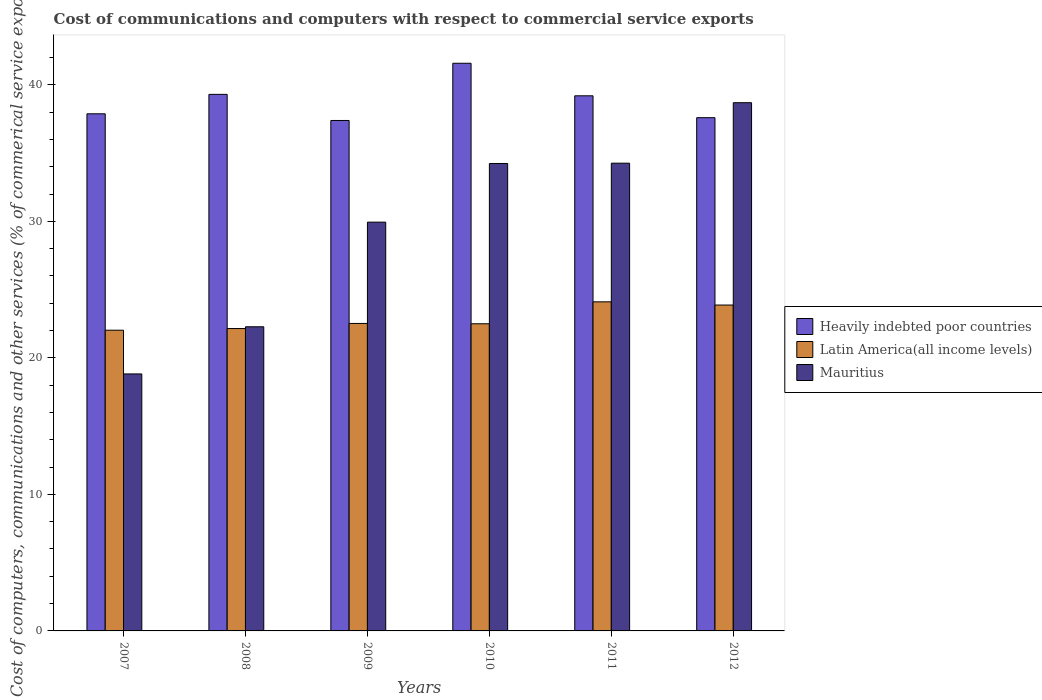How many groups of bars are there?
Provide a succinct answer. 6. What is the label of the 1st group of bars from the left?
Provide a succinct answer. 2007. What is the cost of communications and computers in Heavily indebted poor countries in 2012?
Offer a terse response. 37.59. Across all years, what is the maximum cost of communications and computers in Heavily indebted poor countries?
Keep it short and to the point. 41.58. Across all years, what is the minimum cost of communications and computers in Latin America(all income levels)?
Your response must be concise. 22.02. In which year was the cost of communications and computers in Heavily indebted poor countries maximum?
Your response must be concise. 2010. In which year was the cost of communications and computers in Heavily indebted poor countries minimum?
Give a very brief answer. 2009. What is the total cost of communications and computers in Latin America(all income levels) in the graph?
Your answer should be compact. 137.16. What is the difference between the cost of communications and computers in Mauritius in 2009 and that in 2010?
Provide a succinct answer. -4.3. What is the difference between the cost of communications and computers in Heavily indebted poor countries in 2007 and the cost of communications and computers in Mauritius in 2012?
Ensure brevity in your answer.  -0.81. What is the average cost of communications and computers in Mauritius per year?
Make the answer very short. 29.7. In the year 2012, what is the difference between the cost of communications and computers in Latin America(all income levels) and cost of communications and computers in Heavily indebted poor countries?
Make the answer very short. -13.72. In how many years, is the cost of communications and computers in Latin America(all income levels) greater than 16 %?
Your response must be concise. 6. What is the ratio of the cost of communications and computers in Heavily indebted poor countries in 2007 to that in 2008?
Keep it short and to the point. 0.96. Is the difference between the cost of communications and computers in Latin America(all income levels) in 2009 and 2012 greater than the difference between the cost of communications and computers in Heavily indebted poor countries in 2009 and 2012?
Make the answer very short. No. What is the difference between the highest and the second highest cost of communications and computers in Mauritius?
Offer a terse response. 4.43. What is the difference between the highest and the lowest cost of communications and computers in Latin America(all income levels)?
Provide a succinct answer. 2.08. In how many years, is the cost of communications and computers in Latin America(all income levels) greater than the average cost of communications and computers in Latin America(all income levels) taken over all years?
Your answer should be compact. 2. What does the 3rd bar from the left in 2007 represents?
Your answer should be compact. Mauritius. What does the 3rd bar from the right in 2010 represents?
Ensure brevity in your answer.  Heavily indebted poor countries. Are all the bars in the graph horizontal?
Make the answer very short. No. What is the difference between two consecutive major ticks on the Y-axis?
Keep it short and to the point. 10. Does the graph contain any zero values?
Your answer should be compact. No. Does the graph contain grids?
Keep it short and to the point. No. How many legend labels are there?
Make the answer very short. 3. What is the title of the graph?
Provide a short and direct response. Cost of communications and computers with respect to commercial service exports. What is the label or title of the Y-axis?
Provide a short and direct response. Cost of computers, communications and other services (% of commerical service exports). What is the Cost of computers, communications and other services (% of commerical service exports) of Heavily indebted poor countries in 2007?
Make the answer very short. 37.87. What is the Cost of computers, communications and other services (% of commerical service exports) in Latin America(all income levels) in 2007?
Give a very brief answer. 22.02. What is the Cost of computers, communications and other services (% of commerical service exports) in Mauritius in 2007?
Your answer should be compact. 18.82. What is the Cost of computers, communications and other services (% of commerical service exports) of Heavily indebted poor countries in 2008?
Your response must be concise. 39.3. What is the Cost of computers, communications and other services (% of commerical service exports) in Latin America(all income levels) in 2008?
Your answer should be very brief. 22.15. What is the Cost of computers, communications and other services (% of commerical service exports) in Mauritius in 2008?
Give a very brief answer. 22.28. What is the Cost of computers, communications and other services (% of commerical service exports) in Heavily indebted poor countries in 2009?
Give a very brief answer. 37.39. What is the Cost of computers, communications and other services (% of commerical service exports) of Latin America(all income levels) in 2009?
Provide a short and direct response. 22.52. What is the Cost of computers, communications and other services (% of commerical service exports) of Mauritius in 2009?
Ensure brevity in your answer.  29.94. What is the Cost of computers, communications and other services (% of commerical service exports) of Heavily indebted poor countries in 2010?
Your answer should be very brief. 41.58. What is the Cost of computers, communications and other services (% of commerical service exports) in Latin America(all income levels) in 2010?
Your answer should be compact. 22.5. What is the Cost of computers, communications and other services (% of commerical service exports) in Mauritius in 2010?
Offer a terse response. 34.24. What is the Cost of computers, communications and other services (% of commerical service exports) of Heavily indebted poor countries in 2011?
Your answer should be very brief. 39.19. What is the Cost of computers, communications and other services (% of commerical service exports) of Latin America(all income levels) in 2011?
Your answer should be compact. 24.1. What is the Cost of computers, communications and other services (% of commerical service exports) in Mauritius in 2011?
Give a very brief answer. 34.26. What is the Cost of computers, communications and other services (% of commerical service exports) in Heavily indebted poor countries in 2012?
Provide a succinct answer. 37.59. What is the Cost of computers, communications and other services (% of commerical service exports) in Latin America(all income levels) in 2012?
Provide a succinct answer. 23.87. What is the Cost of computers, communications and other services (% of commerical service exports) of Mauritius in 2012?
Your response must be concise. 38.69. Across all years, what is the maximum Cost of computers, communications and other services (% of commerical service exports) of Heavily indebted poor countries?
Offer a very short reply. 41.58. Across all years, what is the maximum Cost of computers, communications and other services (% of commerical service exports) in Latin America(all income levels)?
Provide a succinct answer. 24.1. Across all years, what is the maximum Cost of computers, communications and other services (% of commerical service exports) of Mauritius?
Make the answer very short. 38.69. Across all years, what is the minimum Cost of computers, communications and other services (% of commerical service exports) in Heavily indebted poor countries?
Provide a short and direct response. 37.39. Across all years, what is the minimum Cost of computers, communications and other services (% of commerical service exports) in Latin America(all income levels)?
Provide a short and direct response. 22.02. Across all years, what is the minimum Cost of computers, communications and other services (% of commerical service exports) of Mauritius?
Offer a terse response. 18.82. What is the total Cost of computers, communications and other services (% of commerical service exports) of Heavily indebted poor countries in the graph?
Your answer should be very brief. 232.92. What is the total Cost of computers, communications and other services (% of commerical service exports) of Latin America(all income levels) in the graph?
Your answer should be very brief. 137.16. What is the total Cost of computers, communications and other services (% of commerical service exports) of Mauritius in the graph?
Make the answer very short. 178.22. What is the difference between the Cost of computers, communications and other services (% of commerical service exports) in Heavily indebted poor countries in 2007 and that in 2008?
Keep it short and to the point. -1.42. What is the difference between the Cost of computers, communications and other services (% of commerical service exports) of Latin America(all income levels) in 2007 and that in 2008?
Give a very brief answer. -0.12. What is the difference between the Cost of computers, communications and other services (% of commerical service exports) of Mauritius in 2007 and that in 2008?
Your response must be concise. -3.45. What is the difference between the Cost of computers, communications and other services (% of commerical service exports) in Heavily indebted poor countries in 2007 and that in 2009?
Your response must be concise. 0.49. What is the difference between the Cost of computers, communications and other services (% of commerical service exports) in Latin America(all income levels) in 2007 and that in 2009?
Offer a very short reply. -0.5. What is the difference between the Cost of computers, communications and other services (% of commerical service exports) in Mauritius in 2007 and that in 2009?
Your answer should be compact. -11.12. What is the difference between the Cost of computers, communications and other services (% of commerical service exports) in Heavily indebted poor countries in 2007 and that in 2010?
Ensure brevity in your answer.  -3.7. What is the difference between the Cost of computers, communications and other services (% of commerical service exports) of Latin America(all income levels) in 2007 and that in 2010?
Make the answer very short. -0.47. What is the difference between the Cost of computers, communications and other services (% of commerical service exports) of Mauritius in 2007 and that in 2010?
Give a very brief answer. -15.41. What is the difference between the Cost of computers, communications and other services (% of commerical service exports) of Heavily indebted poor countries in 2007 and that in 2011?
Provide a short and direct response. -1.32. What is the difference between the Cost of computers, communications and other services (% of commerical service exports) of Latin America(all income levels) in 2007 and that in 2011?
Keep it short and to the point. -2.08. What is the difference between the Cost of computers, communications and other services (% of commerical service exports) of Mauritius in 2007 and that in 2011?
Offer a very short reply. -15.44. What is the difference between the Cost of computers, communications and other services (% of commerical service exports) of Heavily indebted poor countries in 2007 and that in 2012?
Offer a very short reply. 0.28. What is the difference between the Cost of computers, communications and other services (% of commerical service exports) in Latin America(all income levels) in 2007 and that in 2012?
Keep it short and to the point. -1.84. What is the difference between the Cost of computers, communications and other services (% of commerical service exports) in Mauritius in 2007 and that in 2012?
Provide a short and direct response. -19.87. What is the difference between the Cost of computers, communications and other services (% of commerical service exports) of Heavily indebted poor countries in 2008 and that in 2009?
Offer a terse response. 1.91. What is the difference between the Cost of computers, communications and other services (% of commerical service exports) of Latin America(all income levels) in 2008 and that in 2009?
Offer a terse response. -0.37. What is the difference between the Cost of computers, communications and other services (% of commerical service exports) of Mauritius in 2008 and that in 2009?
Offer a very short reply. -7.66. What is the difference between the Cost of computers, communications and other services (% of commerical service exports) of Heavily indebted poor countries in 2008 and that in 2010?
Your answer should be very brief. -2.28. What is the difference between the Cost of computers, communications and other services (% of commerical service exports) of Latin America(all income levels) in 2008 and that in 2010?
Keep it short and to the point. -0.35. What is the difference between the Cost of computers, communications and other services (% of commerical service exports) in Mauritius in 2008 and that in 2010?
Provide a short and direct response. -11.96. What is the difference between the Cost of computers, communications and other services (% of commerical service exports) in Heavily indebted poor countries in 2008 and that in 2011?
Your answer should be compact. 0.1. What is the difference between the Cost of computers, communications and other services (% of commerical service exports) in Latin America(all income levels) in 2008 and that in 2011?
Your answer should be very brief. -1.96. What is the difference between the Cost of computers, communications and other services (% of commerical service exports) of Mauritius in 2008 and that in 2011?
Give a very brief answer. -11.98. What is the difference between the Cost of computers, communications and other services (% of commerical service exports) in Heavily indebted poor countries in 2008 and that in 2012?
Provide a succinct answer. 1.71. What is the difference between the Cost of computers, communications and other services (% of commerical service exports) of Latin America(all income levels) in 2008 and that in 2012?
Provide a short and direct response. -1.72. What is the difference between the Cost of computers, communications and other services (% of commerical service exports) in Mauritius in 2008 and that in 2012?
Give a very brief answer. -16.41. What is the difference between the Cost of computers, communications and other services (% of commerical service exports) of Heavily indebted poor countries in 2009 and that in 2010?
Give a very brief answer. -4.19. What is the difference between the Cost of computers, communications and other services (% of commerical service exports) of Latin America(all income levels) in 2009 and that in 2010?
Your answer should be very brief. 0.02. What is the difference between the Cost of computers, communications and other services (% of commerical service exports) in Mauritius in 2009 and that in 2010?
Offer a terse response. -4.3. What is the difference between the Cost of computers, communications and other services (% of commerical service exports) of Heavily indebted poor countries in 2009 and that in 2011?
Offer a terse response. -1.81. What is the difference between the Cost of computers, communications and other services (% of commerical service exports) in Latin America(all income levels) in 2009 and that in 2011?
Your response must be concise. -1.58. What is the difference between the Cost of computers, communications and other services (% of commerical service exports) in Mauritius in 2009 and that in 2011?
Ensure brevity in your answer.  -4.32. What is the difference between the Cost of computers, communications and other services (% of commerical service exports) in Heavily indebted poor countries in 2009 and that in 2012?
Offer a very short reply. -0.2. What is the difference between the Cost of computers, communications and other services (% of commerical service exports) in Latin America(all income levels) in 2009 and that in 2012?
Offer a very short reply. -1.35. What is the difference between the Cost of computers, communications and other services (% of commerical service exports) in Mauritius in 2009 and that in 2012?
Offer a very short reply. -8.75. What is the difference between the Cost of computers, communications and other services (% of commerical service exports) in Heavily indebted poor countries in 2010 and that in 2011?
Your answer should be compact. 2.38. What is the difference between the Cost of computers, communications and other services (% of commerical service exports) of Latin America(all income levels) in 2010 and that in 2011?
Provide a succinct answer. -1.61. What is the difference between the Cost of computers, communications and other services (% of commerical service exports) of Mauritius in 2010 and that in 2011?
Make the answer very short. -0.02. What is the difference between the Cost of computers, communications and other services (% of commerical service exports) in Heavily indebted poor countries in 2010 and that in 2012?
Your answer should be compact. 3.99. What is the difference between the Cost of computers, communications and other services (% of commerical service exports) in Latin America(all income levels) in 2010 and that in 2012?
Your answer should be very brief. -1.37. What is the difference between the Cost of computers, communications and other services (% of commerical service exports) in Mauritius in 2010 and that in 2012?
Provide a succinct answer. -4.45. What is the difference between the Cost of computers, communications and other services (% of commerical service exports) in Heavily indebted poor countries in 2011 and that in 2012?
Offer a very short reply. 1.6. What is the difference between the Cost of computers, communications and other services (% of commerical service exports) in Latin America(all income levels) in 2011 and that in 2012?
Your answer should be very brief. 0.24. What is the difference between the Cost of computers, communications and other services (% of commerical service exports) of Mauritius in 2011 and that in 2012?
Make the answer very short. -4.43. What is the difference between the Cost of computers, communications and other services (% of commerical service exports) of Heavily indebted poor countries in 2007 and the Cost of computers, communications and other services (% of commerical service exports) of Latin America(all income levels) in 2008?
Your response must be concise. 15.73. What is the difference between the Cost of computers, communications and other services (% of commerical service exports) in Heavily indebted poor countries in 2007 and the Cost of computers, communications and other services (% of commerical service exports) in Mauritius in 2008?
Make the answer very short. 15.6. What is the difference between the Cost of computers, communications and other services (% of commerical service exports) in Latin America(all income levels) in 2007 and the Cost of computers, communications and other services (% of commerical service exports) in Mauritius in 2008?
Keep it short and to the point. -0.25. What is the difference between the Cost of computers, communications and other services (% of commerical service exports) in Heavily indebted poor countries in 2007 and the Cost of computers, communications and other services (% of commerical service exports) in Latin America(all income levels) in 2009?
Make the answer very short. 15.35. What is the difference between the Cost of computers, communications and other services (% of commerical service exports) of Heavily indebted poor countries in 2007 and the Cost of computers, communications and other services (% of commerical service exports) of Mauritius in 2009?
Ensure brevity in your answer.  7.93. What is the difference between the Cost of computers, communications and other services (% of commerical service exports) of Latin America(all income levels) in 2007 and the Cost of computers, communications and other services (% of commerical service exports) of Mauritius in 2009?
Ensure brevity in your answer.  -7.92. What is the difference between the Cost of computers, communications and other services (% of commerical service exports) of Heavily indebted poor countries in 2007 and the Cost of computers, communications and other services (% of commerical service exports) of Latin America(all income levels) in 2010?
Keep it short and to the point. 15.38. What is the difference between the Cost of computers, communications and other services (% of commerical service exports) in Heavily indebted poor countries in 2007 and the Cost of computers, communications and other services (% of commerical service exports) in Mauritius in 2010?
Provide a short and direct response. 3.64. What is the difference between the Cost of computers, communications and other services (% of commerical service exports) of Latin America(all income levels) in 2007 and the Cost of computers, communications and other services (% of commerical service exports) of Mauritius in 2010?
Make the answer very short. -12.21. What is the difference between the Cost of computers, communications and other services (% of commerical service exports) of Heavily indebted poor countries in 2007 and the Cost of computers, communications and other services (% of commerical service exports) of Latin America(all income levels) in 2011?
Ensure brevity in your answer.  13.77. What is the difference between the Cost of computers, communications and other services (% of commerical service exports) of Heavily indebted poor countries in 2007 and the Cost of computers, communications and other services (% of commerical service exports) of Mauritius in 2011?
Ensure brevity in your answer.  3.62. What is the difference between the Cost of computers, communications and other services (% of commerical service exports) of Latin America(all income levels) in 2007 and the Cost of computers, communications and other services (% of commerical service exports) of Mauritius in 2011?
Keep it short and to the point. -12.23. What is the difference between the Cost of computers, communications and other services (% of commerical service exports) in Heavily indebted poor countries in 2007 and the Cost of computers, communications and other services (% of commerical service exports) in Latin America(all income levels) in 2012?
Give a very brief answer. 14.01. What is the difference between the Cost of computers, communications and other services (% of commerical service exports) in Heavily indebted poor countries in 2007 and the Cost of computers, communications and other services (% of commerical service exports) in Mauritius in 2012?
Make the answer very short. -0.81. What is the difference between the Cost of computers, communications and other services (% of commerical service exports) of Latin America(all income levels) in 2007 and the Cost of computers, communications and other services (% of commerical service exports) of Mauritius in 2012?
Provide a short and direct response. -16.66. What is the difference between the Cost of computers, communications and other services (% of commerical service exports) of Heavily indebted poor countries in 2008 and the Cost of computers, communications and other services (% of commerical service exports) of Latin America(all income levels) in 2009?
Your answer should be very brief. 16.78. What is the difference between the Cost of computers, communications and other services (% of commerical service exports) of Heavily indebted poor countries in 2008 and the Cost of computers, communications and other services (% of commerical service exports) of Mauritius in 2009?
Your response must be concise. 9.36. What is the difference between the Cost of computers, communications and other services (% of commerical service exports) in Latin America(all income levels) in 2008 and the Cost of computers, communications and other services (% of commerical service exports) in Mauritius in 2009?
Make the answer very short. -7.79. What is the difference between the Cost of computers, communications and other services (% of commerical service exports) in Heavily indebted poor countries in 2008 and the Cost of computers, communications and other services (% of commerical service exports) in Latin America(all income levels) in 2010?
Your response must be concise. 16.8. What is the difference between the Cost of computers, communications and other services (% of commerical service exports) in Heavily indebted poor countries in 2008 and the Cost of computers, communications and other services (% of commerical service exports) in Mauritius in 2010?
Offer a very short reply. 5.06. What is the difference between the Cost of computers, communications and other services (% of commerical service exports) in Latin America(all income levels) in 2008 and the Cost of computers, communications and other services (% of commerical service exports) in Mauritius in 2010?
Provide a succinct answer. -12.09. What is the difference between the Cost of computers, communications and other services (% of commerical service exports) of Heavily indebted poor countries in 2008 and the Cost of computers, communications and other services (% of commerical service exports) of Latin America(all income levels) in 2011?
Provide a short and direct response. 15.19. What is the difference between the Cost of computers, communications and other services (% of commerical service exports) of Heavily indebted poor countries in 2008 and the Cost of computers, communications and other services (% of commerical service exports) of Mauritius in 2011?
Your response must be concise. 5.04. What is the difference between the Cost of computers, communications and other services (% of commerical service exports) in Latin America(all income levels) in 2008 and the Cost of computers, communications and other services (% of commerical service exports) in Mauritius in 2011?
Your answer should be compact. -12.11. What is the difference between the Cost of computers, communications and other services (% of commerical service exports) in Heavily indebted poor countries in 2008 and the Cost of computers, communications and other services (% of commerical service exports) in Latin America(all income levels) in 2012?
Your answer should be compact. 15.43. What is the difference between the Cost of computers, communications and other services (% of commerical service exports) of Heavily indebted poor countries in 2008 and the Cost of computers, communications and other services (% of commerical service exports) of Mauritius in 2012?
Offer a terse response. 0.61. What is the difference between the Cost of computers, communications and other services (% of commerical service exports) of Latin America(all income levels) in 2008 and the Cost of computers, communications and other services (% of commerical service exports) of Mauritius in 2012?
Make the answer very short. -16.54. What is the difference between the Cost of computers, communications and other services (% of commerical service exports) of Heavily indebted poor countries in 2009 and the Cost of computers, communications and other services (% of commerical service exports) of Latin America(all income levels) in 2010?
Keep it short and to the point. 14.89. What is the difference between the Cost of computers, communications and other services (% of commerical service exports) of Heavily indebted poor countries in 2009 and the Cost of computers, communications and other services (% of commerical service exports) of Mauritius in 2010?
Provide a succinct answer. 3.15. What is the difference between the Cost of computers, communications and other services (% of commerical service exports) of Latin America(all income levels) in 2009 and the Cost of computers, communications and other services (% of commerical service exports) of Mauritius in 2010?
Your response must be concise. -11.72. What is the difference between the Cost of computers, communications and other services (% of commerical service exports) of Heavily indebted poor countries in 2009 and the Cost of computers, communications and other services (% of commerical service exports) of Latin America(all income levels) in 2011?
Provide a succinct answer. 13.28. What is the difference between the Cost of computers, communications and other services (% of commerical service exports) of Heavily indebted poor countries in 2009 and the Cost of computers, communications and other services (% of commerical service exports) of Mauritius in 2011?
Make the answer very short. 3.13. What is the difference between the Cost of computers, communications and other services (% of commerical service exports) of Latin America(all income levels) in 2009 and the Cost of computers, communications and other services (% of commerical service exports) of Mauritius in 2011?
Your answer should be very brief. -11.74. What is the difference between the Cost of computers, communications and other services (% of commerical service exports) of Heavily indebted poor countries in 2009 and the Cost of computers, communications and other services (% of commerical service exports) of Latin America(all income levels) in 2012?
Ensure brevity in your answer.  13.52. What is the difference between the Cost of computers, communications and other services (% of commerical service exports) in Heavily indebted poor countries in 2009 and the Cost of computers, communications and other services (% of commerical service exports) in Mauritius in 2012?
Your response must be concise. -1.3. What is the difference between the Cost of computers, communications and other services (% of commerical service exports) in Latin America(all income levels) in 2009 and the Cost of computers, communications and other services (% of commerical service exports) in Mauritius in 2012?
Keep it short and to the point. -16.17. What is the difference between the Cost of computers, communications and other services (% of commerical service exports) in Heavily indebted poor countries in 2010 and the Cost of computers, communications and other services (% of commerical service exports) in Latin America(all income levels) in 2011?
Provide a short and direct response. 17.47. What is the difference between the Cost of computers, communications and other services (% of commerical service exports) of Heavily indebted poor countries in 2010 and the Cost of computers, communications and other services (% of commerical service exports) of Mauritius in 2011?
Your response must be concise. 7.32. What is the difference between the Cost of computers, communications and other services (% of commerical service exports) in Latin America(all income levels) in 2010 and the Cost of computers, communications and other services (% of commerical service exports) in Mauritius in 2011?
Give a very brief answer. -11.76. What is the difference between the Cost of computers, communications and other services (% of commerical service exports) of Heavily indebted poor countries in 2010 and the Cost of computers, communications and other services (% of commerical service exports) of Latin America(all income levels) in 2012?
Provide a short and direct response. 17.71. What is the difference between the Cost of computers, communications and other services (% of commerical service exports) of Heavily indebted poor countries in 2010 and the Cost of computers, communications and other services (% of commerical service exports) of Mauritius in 2012?
Give a very brief answer. 2.89. What is the difference between the Cost of computers, communications and other services (% of commerical service exports) of Latin America(all income levels) in 2010 and the Cost of computers, communications and other services (% of commerical service exports) of Mauritius in 2012?
Give a very brief answer. -16.19. What is the difference between the Cost of computers, communications and other services (% of commerical service exports) of Heavily indebted poor countries in 2011 and the Cost of computers, communications and other services (% of commerical service exports) of Latin America(all income levels) in 2012?
Your answer should be compact. 15.32. What is the difference between the Cost of computers, communications and other services (% of commerical service exports) of Heavily indebted poor countries in 2011 and the Cost of computers, communications and other services (% of commerical service exports) of Mauritius in 2012?
Offer a terse response. 0.51. What is the difference between the Cost of computers, communications and other services (% of commerical service exports) of Latin America(all income levels) in 2011 and the Cost of computers, communications and other services (% of commerical service exports) of Mauritius in 2012?
Offer a very short reply. -14.58. What is the average Cost of computers, communications and other services (% of commerical service exports) of Heavily indebted poor countries per year?
Make the answer very short. 38.82. What is the average Cost of computers, communications and other services (% of commerical service exports) in Latin America(all income levels) per year?
Offer a very short reply. 22.86. What is the average Cost of computers, communications and other services (% of commerical service exports) in Mauritius per year?
Provide a short and direct response. 29.7. In the year 2007, what is the difference between the Cost of computers, communications and other services (% of commerical service exports) in Heavily indebted poor countries and Cost of computers, communications and other services (% of commerical service exports) in Latin America(all income levels)?
Your response must be concise. 15.85. In the year 2007, what is the difference between the Cost of computers, communications and other services (% of commerical service exports) in Heavily indebted poor countries and Cost of computers, communications and other services (% of commerical service exports) in Mauritius?
Offer a very short reply. 19.05. In the year 2007, what is the difference between the Cost of computers, communications and other services (% of commerical service exports) of Latin America(all income levels) and Cost of computers, communications and other services (% of commerical service exports) of Mauritius?
Make the answer very short. 3.2. In the year 2008, what is the difference between the Cost of computers, communications and other services (% of commerical service exports) in Heavily indebted poor countries and Cost of computers, communications and other services (% of commerical service exports) in Latin America(all income levels)?
Offer a terse response. 17.15. In the year 2008, what is the difference between the Cost of computers, communications and other services (% of commerical service exports) in Heavily indebted poor countries and Cost of computers, communications and other services (% of commerical service exports) in Mauritius?
Keep it short and to the point. 17.02. In the year 2008, what is the difference between the Cost of computers, communications and other services (% of commerical service exports) of Latin America(all income levels) and Cost of computers, communications and other services (% of commerical service exports) of Mauritius?
Provide a short and direct response. -0.13. In the year 2009, what is the difference between the Cost of computers, communications and other services (% of commerical service exports) of Heavily indebted poor countries and Cost of computers, communications and other services (% of commerical service exports) of Latin America(all income levels)?
Your answer should be very brief. 14.87. In the year 2009, what is the difference between the Cost of computers, communications and other services (% of commerical service exports) in Heavily indebted poor countries and Cost of computers, communications and other services (% of commerical service exports) in Mauritius?
Give a very brief answer. 7.45. In the year 2009, what is the difference between the Cost of computers, communications and other services (% of commerical service exports) in Latin America(all income levels) and Cost of computers, communications and other services (% of commerical service exports) in Mauritius?
Make the answer very short. -7.42. In the year 2010, what is the difference between the Cost of computers, communications and other services (% of commerical service exports) in Heavily indebted poor countries and Cost of computers, communications and other services (% of commerical service exports) in Latin America(all income levels)?
Your response must be concise. 19.08. In the year 2010, what is the difference between the Cost of computers, communications and other services (% of commerical service exports) in Heavily indebted poor countries and Cost of computers, communications and other services (% of commerical service exports) in Mauritius?
Make the answer very short. 7.34. In the year 2010, what is the difference between the Cost of computers, communications and other services (% of commerical service exports) in Latin America(all income levels) and Cost of computers, communications and other services (% of commerical service exports) in Mauritius?
Your answer should be compact. -11.74. In the year 2011, what is the difference between the Cost of computers, communications and other services (% of commerical service exports) of Heavily indebted poor countries and Cost of computers, communications and other services (% of commerical service exports) of Latin America(all income levels)?
Provide a succinct answer. 15.09. In the year 2011, what is the difference between the Cost of computers, communications and other services (% of commerical service exports) of Heavily indebted poor countries and Cost of computers, communications and other services (% of commerical service exports) of Mauritius?
Provide a succinct answer. 4.93. In the year 2011, what is the difference between the Cost of computers, communications and other services (% of commerical service exports) of Latin America(all income levels) and Cost of computers, communications and other services (% of commerical service exports) of Mauritius?
Offer a very short reply. -10.16. In the year 2012, what is the difference between the Cost of computers, communications and other services (% of commerical service exports) of Heavily indebted poor countries and Cost of computers, communications and other services (% of commerical service exports) of Latin America(all income levels)?
Make the answer very short. 13.72. In the year 2012, what is the difference between the Cost of computers, communications and other services (% of commerical service exports) in Heavily indebted poor countries and Cost of computers, communications and other services (% of commerical service exports) in Mauritius?
Provide a succinct answer. -1.1. In the year 2012, what is the difference between the Cost of computers, communications and other services (% of commerical service exports) of Latin America(all income levels) and Cost of computers, communications and other services (% of commerical service exports) of Mauritius?
Offer a very short reply. -14.82. What is the ratio of the Cost of computers, communications and other services (% of commerical service exports) in Heavily indebted poor countries in 2007 to that in 2008?
Your answer should be compact. 0.96. What is the ratio of the Cost of computers, communications and other services (% of commerical service exports) of Mauritius in 2007 to that in 2008?
Offer a terse response. 0.84. What is the ratio of the Cost of computers, communications and other services (% of commerical service exports) of Heavily indebted poor countries in 2007 to that in 2009?
Offer a very short reply. 1.01. What is the ratio of the Cost of computers, communications and other services (% of commerical service exports) of Latin America(all income levels) in 2007 to that in 2009?
Your response must be concise. 0.98. What is the ratio of the Cost of computers, communications and other services (% of commerical service exports) of Mauritius in 2007 to that in 2009?
Your response must be concise. 0.63. What is the ratio of the Cost of computers, communications and other services (% of commerical service exports) of Heavily indebted poor countries in 2007 to that in 2010?
Your response must be concise. 0.91. What is the ratio of the Cost of computers, communications and other services (% of commerical service exports) of Latin America(all income levels) in 2007 to that in 2010?
Your answer should be very brief. 0.98. What is the ratio of the Cost of computers, communications and other services (% of commerical service exports) of Mauritius in 2007 to that in 2010?
Your answer should be compact. 0.55. What is the ratio of the Cost of computers, communications and other services (% of commerical service exports) in Heavily indebted poor countries in 2007 to that in 2011?
Ensure brevity in your answer.  0.97. What is the ratio of the Cost of computers, communications and other services (% of commerical service exports) of Latin America(all income levels) in 2007 to that in 2011?
Offer a terse response. 0.91. What is the ratio of the Cost of computers, communications and other services (% of commerical service exports) of Mauritius in 2007 to that in 2011?
Provide a succinct answer. 0.55. What is the ratio of the Cost of computers, communications and other services (% of commerical service exports) of Heavily indebted poor countries in 2007 to that in 2012?
Make the answer very short. 1.01. What is the ratio of the Cost of computers, communications and other services (% of commerical service exports) of Latin America(all income levels) in 2007 to that in 2012?
Your answer should be very brief. 0.92. What is the ratio of the Cost of computers, communications and other services (% of commerical service exports) in Mauritius in 2007 to that in 2012?
Keep it short and to the point. 0.49. What is the ratio of the Cost of computers, communications and other services (% of commerical service exports) of Heavily indebted poor countries in 2008 to that in 2009?
Make the answer very short. 1.05. What is the ratio of the Cost of computers, communications and other services (% of commerical service exports) in Latin America(all income levels) in 2008 to that in 2009?
Make the answer very short. 0.98. What is the ratio of the Cost of computers, communications and other services (% of commerical service exports) of Mauritius in 2008 to that in 2009?
Offer a very short reply. 0.74. What is the ratio of the Cost of computers, communications and other services (% of commerical service exports) in Heavily indebted poor countries in 2008 to that in 2010?
Offer a terse response. 0.95. What is the ratio of the Cost of computers, communications and other services (% of commerical service exports) of Latin America(all income levels) in 2008 to that in 2010?
Give a very brief answer. 0.98. What is the ratio of the Cost of computers, communications and other services (% of commerical service exports) of Mauritius in 2008 to that in 2010?
Your answer should be very brief. 0.65. What is the ratio of the Cost of computers, communications and other services (% of commerical service exports) in Heavily indebted poor countries in 2008 to that in 2011?
Your response must be concise. 1. What is the ratio of the Cost of computers, communications and other services (% of commerical service exports) in Latin America(all income levels) in 2008 to that in 2011?
Your answer should be compact. 0.92. What is the ratio of the Cost of computers, communications and other services (% of commerical service exports) of Mauritius in 2008 to that in 2011?
Keep it short and to the point. 0.65. What is the ratio of the Cost of computers, communications and other services (% of commerical service exports) of Heavily indebted poor countries in 2008 to that in 2012?
Give a very brief answer. 1.05. What is the ratio of the Cost of computers, communications and other services (% of commerical service exports) of Latin America(all income levels) in 2008 to that in 2012?
Offer a very short reply. 0.93. What is the ratio of the Cost of computers, communications and other services (% of commerical service exports) of Mauritius in 2008 to that in 2012?
Your answer should be compact. 0.58. What is the ratio of the Cost of computers, communications and other services (% of commerical service exports) of Heavily indebted poor countries in 2009 to that in 2010?
Your answer should be very brief. 0.9. What is the ratio of the Cost of computers, communications and other services (% of commerical service exports) in Mauritius in 2009 to that in 2010?
Your answer should be compact. 0.87. What is the ratio of the Cost of computers, communications and other services (% of commerical service exports) of Heavily indebted poor countries in 2009 to that in 2011?
Provide a succinct answer. 0.95. What is the ratio of the Cost of computers, communications and other services (% of commerical service exports) of Latin America(all income levels) in 2009 to that in 2011?
Provide a succinct answer. 0.93. What is the ratio of the Cost of computers, communications and other services (% of commerical service exports) of Mauritius in 2009 to that in 2011?
Keep it short and to the point. 0.87. What is the ratio of the Cost of computers, communications and other services (% of commerical service exports) in Heavily indebted poor countries in 2009 to that in 2012?
Your answer should be compact. 0.99. What is the ratio of the Cost of computers, communications and other services (% of commerical service exports) of Latin America(all income levels) in 2009 to that in 2012?
Offer a terse response. 0.94. What is the ratio of the Cost of computers, communications and other services (% of commerical service exports) of Mauritius in 2009 to that in 2012?
Provide a short and direct response. 0.77. What is the ratio of the Cost of computers, communications and other services (% of commerical service exports) in Heavily indebted poor countries in 2010 to that in 2011?
Ensure brevity in your answer.  1.06. What is the ratio of the Cost of computers, communications and other services (% of commerical service exports) of Latin America(all income levels) in 2010 to that in 2011?
Offer a very short reply. 0.93. What is the ratio of the Cost of computers, communications and other services (% of commerical service exports) in Heavily indebted poor countries in 2010 to that in 2012?
Offer a terse response. 1.11. What is the ratio of the Cost of computers, communications and other services (% of commerical service exports) in Latin America(all income levels) in 2010 to that in 2012?
Offer a terse response. 0.94. What is the ratio of the Cost of computers, communications and other services (% of commerical service exports) in Mauritius in 2010 to that in 2012?
Your answer should be compact. 0.88. What is the ratio of the Cost of computers, communications and other services (% of commerical service exports) in Heavily indebted poor countries in 2011 to that in 2012?
Provide a short and direct response. 1.04. What is the ratio of the Cost of computers, communications and other services (% of commerical service exports) of Latin America(all income levels) in 2011 to that in 2012?
Ensure brevity in your answer.  1.01. What is the ratio of the Cost of computers, communications and other services (% of commerical service exports) of Mauritius in 2011 to that in 2012?
Ensure brevity in your answer.  0.89. What is the difference between the highest and the second highest Cost of computers, communications and other services (% of commerical service exports) in Heavily indebted poor countries?
Offer a terse response. 2.28. What is the difference between the highest and the second highest Cost of computers, communications and other services (% of commerical service exports) of Latin America(all income levels)?
Your answer should be very brief. 0.24. What is the difference between the highest and the second highest Cost of computers, communications and other services (% of commerical service exports) in Mauritius?
Keep it short and to the point. 4.43. What is the difference between the highest and the lowest Cost of computers, communications and other services (% of commerical service exports) of Heavily indebted poor countries?
Provide a short and direct response. 4.19. What is the difference between the highest and the lowest Cost of computers, communications and other services (% of commerical service exports) of Latin America(all income levels)?
Give a very brief answer. 2.08. What is the difference between the highest and the lowest Cost of computers, communications and other services (% of commerical service exports) in Mauritius?
Ensure brevity in your answer.  19.87. 